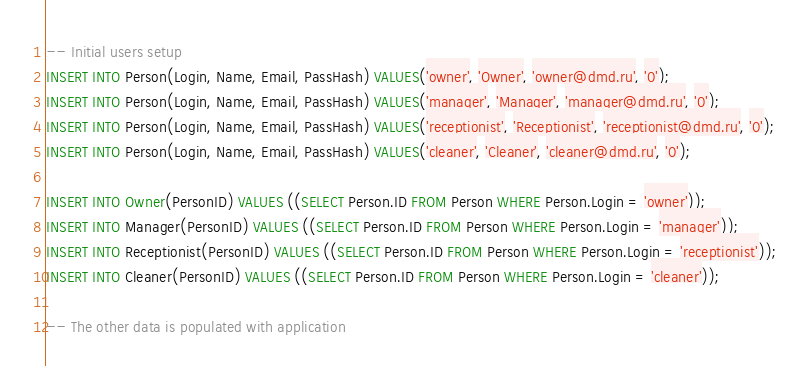Convert code to text. <code><loc_0><loc_0><loc_500><loc_500><_SQL_>-- Initial users setup
INSERT INTO Person(Login, Name, Email, PassHash) VALUES('owner', 'Owner', 'owner@dmd.ru', '0');
INSERT INTO Person(Login, Name, Email, PassHash) VALUES('manager', 'Manager', 'manager@dmd.ru', '0');
INSERT INTO Person(Login, Name, Email, PassHash) VALUES('receptionist', 'Receptionist', 'receptionist@dmd.ru', '0');
INSERT INTO Person(Login, Name, Email, PassHash) VALUES('cleaner', 'Cleaner', 'cleaner@dmd.ru', '0');

INSERT INTO Owner(PersonID) VALUES ((SELECT Person.ID FROM Person WHERE Person.Login = 'owner'));
INSERT INTO Manager(PersonID) VALUES ((SELECT Person.ID FROM Person WHERE Person.Login = 'manager'));
INSERT INTO Receptionist(PersonID) VALUES ((SELECT Person.ID FROM Person WHERE Person.Login = 'receptionist'));
INSERT INTO Cleaner(PersonID) VALUES ((SELECT Person.ID FROM Person WHERE Person.Login = 'cleaner'));

-- The other data is populated with application</code> 